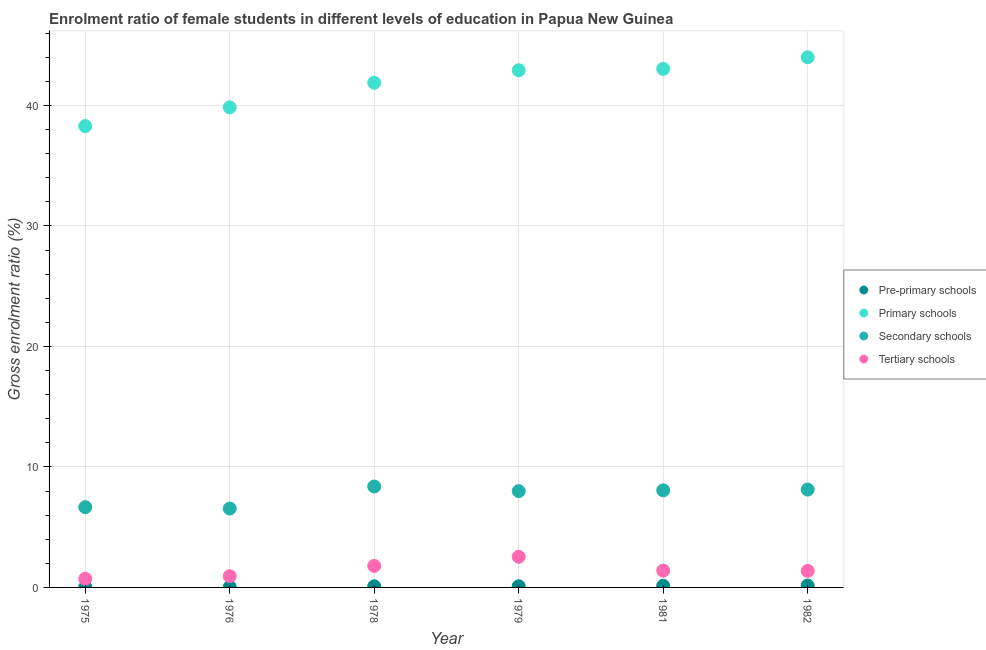How many different coloured dotlines are there?
Offer a terse response. 4. What is the gross enrolment ratio(male) in secondary schools in 1975?
Provide a succinct answer. 6.66. Across all years, what is the maximum gross enrolment ratio(male) in tertiary schools?
Your response must be concise. 2.54. Across all years, what is the minimum gross enrolment ratio(male) in secondary schools?
Your answer should be very brief. 6.55. In which year was the gross enrolment ratio(male) in tertiary schools maximum?
Your answer should be compact. 1979. In which year was the gross enrolment ratio(male) in tertiary schools minimum?
Offer a terse response. 1975. What is the total gross enrolment ratio(male) in primary schools in the graph?
Give a very brief answer. 249.93. What is the difference between the gross enrolment ratio(male) in tertiary schools in 1981 and that in 1982?
Keep it short and to the point. 0.02. What is the difference between the gross enrolment ratio(male) in pre-primary schools in 1981 and the gross enrolment ratio(male) in primary schools in 1979?
Your response must be concise. -42.78. What is the average gross enrolment ratio(male) in primary schools per year?
Offer a very short reply. 41.66. In the year 1978, what is the difference between the gross enrolment ratio(male) in tertiary schools and gross enrolment ratio(male) in pre-primary schools?
Provide a succinct answer. 1.69. What is the ratio of the gross enrolment ratio(male) in pre-primary schools in 1976 to that in 1979?
Offer a very short reply. 0.39. Is the gross enrolment ratio(male) in primary schools in 1979 less than that in 1982?
Offer a very short reply. Yes. What is the difference between the highest and the second highest gross enrolment ratio(male) in primary schools?
Offer a very short reply. 0.96. What is the difference between the highest and the lowest gross enrolment ratio(male) in secondary schools?
Give a very brief answer. 1.83. In how many years, is the gross enrolment ratio(male) in tertiary schools greater than the average gross enrolment ratio(male) in tertiary schools taken over all years?
Give a very brief answer. 2. Is it the case that in every year, the sum of the gross enrolment ratio(male) in tertiary schools and gross enrolment ratio(male) in primary schools is greater than the sum of gross enrolment ratio(male) in pre-primary schools and gross enrolment ratio(male) in secondary schools?
Offer a terse response. No. Is it the case that in every year, the sum of the gross enrolment ratio(male) in pre-primary schools and gross enrolment ratio(male) in primary schools is greater than the gross enrolment ratio(male) in secondary schools?
Your answer should be very brief. Yes. Is the gross enrolment ratio(male) in pre-primary schools strictly less than the gross enrolment ratio(male) in secondary schools over the years?
Your answer should be compact. Yes. How many years are there in the graph?
Your response must be concise. 6. Does the graph contain any zero values?
Your response must be concise. No. Does the graph contain grids?
Your answer should be compact. Yes. How many legend labels are there?
Give a very brief answer. 4. What is the title of the graph?
Keep it short and to the point. Enrolment ratio of female students in different levels of education in Papua New Guinea. Does "UNPBF" appear as one of the legend labels in the graph?
Offer a terse response. No. What is the label or title of the X-axis?
Offer a terse response. Year. What is the label or title of the Y-axis?
Ensure brevity in your answer.  Gross enrolment ratio (%). What is the Gross enrolment ratio (%) in Pre-primary schools in 1975?
Provide a short and direct response. 0.03. What is the Gross enrolment ratio (%) of Primary schools in 1975?
Provide a succinct answer. 38.28. What is the Gross enrolment ratio (%) in Secondary schools in 1975?
Make the answer very short. 6.66. What is the Gross enrolment ratio (%) of Tertiary schools in 1975?
Keep it short and to the point. 0.72. What is the Gross enrolment ratio (%) in Pre-primary schools in 1976?
Provide a succinct answer. 0.04. What is the Gross enrolment ratio (%) in Primary schools in 1976?
Offer a very short reply. 39.84. What is the Gross enrolment ratio (%) of Secondary schools in 1976?
Offer a terse response. 6.55. What is the Gross enrolment ratio (%) of Tertiary schools in 1976?
Offer a terse response. 0.93. What is the Gross enrolment ratio (%) in Pre-primary schools in 1978?
Your response must be concise. 0.09. What is the Gross enrolment ratio (%) of Primary schools in 1978?
Your response must be concise. 41.88. What is the Gross enrolment ratio (%) in Secondary schools in 1978?
Your answer should be very brief. 8.37. What is the Gross enrolment ratio (%) of Tertiary schools in 1978?
Your response must be concise. 1.79. What is the Gross enrolment ratio (%) of Pre-primary schools in 1979?
Make the answer very short. 0.1. What is the Gross enrolment ratio (%) of Primary schools in 1979?
Your answer should be very brief. 42.92. What is the Gross enrolment ratio (%) of Secondary schools in 1979?
Provide a succinct answer. 7.99. What is the Gross enrolment ratio (%) of Tertiary schools in 1979?
Provide a short and direct response. 2.54. What is the Gross enrolment ratio (%) of Pre-primary schools in 1981?
Your response must be concise. 0.14. What is the Gross enrolment ratio (%) of Primary schools in 1981?
Your answer should be compact. 43.03. What is the Gross enrolment ratio (%) in Secondary schools in 1981?
Your answer should be compact. 8.06. What is the Gross enrolment ratio (%) of Tertiary schools in 1981?
Offer a very short reply. 1.39. What is the Gross enrolment ratio (%) in Pre-primary schools in 1982?
Offer a very short reply. 0.15. What is the Gross enrolment ratio (%) of Primary schools in 1982?
Provide a succinct answer. 43.99. What is the Gross enrolment ratio (%) of Secondary schools in 1982?
Your answer should be very brief. 8.12. What is the Gross enrolment ratio (%) in Tertiary schools in 1982?
Provide a succinct answer. 1.37. Across all years, what is the maximum Gross enrolment ratio (%) of Pre-primary schools?
Offer a very short reply. 0.15. Across all years, what is the maximum Gross enrolment ratio (%) of Primary schools?
Your answer should be very brief. 43.99. Across all years, what is the maximum Gross enrolment ratio (%) of Secondary schools?
Offer a very short reply. 8.37. Across all years, what is the maximum Gross enrolment ratio (%) in Tertiary schools?
Keep it short and to the point. 2.54. Across all years, what is the minimum Gross enrolment ratio (%) in Pre-primary schools?
Keep it short and to the point. 0.03. Across all years, what is the minimum Gross enrolment ratio (%) of Primary schools?
Offer a very short reply. 38.28. Across all years, what is the minimum Gross enrolment ratio (%) in Secondary schools?
Make the answer very short. 6.55. Across all years, what is the minimum Gross enrolment ratio (%) in Tertiary schools?
Give a very brief answer. 0.72. What is the total Gross enrolment ratio (%) in Pre-primary schools in the graph?
Keep it short and to the point. 0.54. What is the total Gross enrolment ratio (%) of Primary schools in the graph?
Provide a short and direct response. 249.93. What is the total Gross enrolment ratio (%) of Secondary schools in the graph?
Your answer should be very brief. 45.75. What is the total Gross enrolment ratio (%) in Tertiary schools in the graph?
Provide a succinct answer. 8.74. What is the difference between the Gross enrolment ratio (%) of Pre-primary schools in 1975 and that in 1976?
Provide a succinct answer. -0.01. What is the difference between the Gross enrolment ratio (%) of Primary schools in 1975 and that in 1976?
Provide a succinct answer. -1.55. What is the difference between the Gross enrolment ratio (%) of Secondary schools in 1975 and that in 1976?
Your response must be concise. 0.11. What is the difference between the Gross enrolment ratio (%) of Tertiary schools in 1975 and that in 1976?
Give a very brief answer. -0.21. What is the difference between the Gross enrolment ratio (%) of Pre-primary schools in 1975 and that in 1978?
Provide a short and direct response. -0.07. What is the difference between the Gross enrolment ratio (%) in Primary schools in 1975 and that in 1978?
Your response must be concise. -3.6. What is the difference between the Gross enrolment ratio (%) in Secondary schools in 1975 and that in 1978?
Keep it short and to the point. -1.72. What is the difference between the Gross enrolment ratio (%) in Tertiary schools in 1975 and that in 1978?
Your answer should be compact. -1.07. What is the difference between the Gross enrolment ratio (%) in Pre-primary schools in 1975 and that in 1979?
Your answer should be compact. -0.07. What is the difference between the Gross enrolment ratio (%) in Primary schools in 1975 and that in 1979?
Give a very brief answer. -4.63. What is the difference between the Gross enrolment ratio (%) in Secondary schools in 1975 and that in 1979?
Your answer should be compact. -1.33. What is the difference between the Gross enrolment ratio (%) in Tertiary schools in 1975 and that in 1979?
Offer a terse response. -1.82. What is the difference between the Gross enrolment ratio (%) of Pre-primary schools in 1975 and that in 1981?
Offer a very short reply. -0.11. What is the difference between the Gross enrolment ratio (%) in Primary schools in 1975 and that in 1981?
Offer a very short reply. -4.75. What is the difference between the Gross enrolment ratio (%) of Secondary schools in 1975 and that in 1981?
Keep it short and to the point. -1.4. What is the difference between the Gross enrolment ratio (%) in Tertiary schools in 1975 and that in 1981?
Give a very brief answer. -0.67. What is the difference between the Gross enrolment ratio (%) in Pre-primary schools in 1975 and that in 1982?
Your response must be concise. -0.13. What is the difference between the Gross enrolment ratio (%) in Primary schools in 1975 and that in 1982?
Provide a succinct answer. -5.71. What is the difference between the Gross enrolment ratio (%) in Secondary schools in 1975 and that in 1982?
Offer a very short reply. -1.46. What is the difference between the Gross enrolment ratio (%) of Tertiary schools in 1975 and that in 1982?
Ensure brevity in your answer.  -0.65. What is the difference between the Gross enrolment ratio (%) of Pre-primary schools in 1976 and that in 1978?
Keep it short and to the point. -0.06. What is the difference between the Gross enrolment ratio (%) of Primary schools in 1976 and that in 1978?
Provide a succinct answer. -2.04. What is the difference between the Gross enrolment ratio (%) in Secondary schools in 1976 and that in 1978?
Make the answer very short. -1.83. What is the difference between the Gross enrolment ratio (%) of Tertiary schools in 1976 and that in 1978?
Provide a succinct answer. -0.85. What is the difference between the Gross enrolment ratio (%) in Pre-primary schools in 1976 and that in 1979?
Your answer should be compact. -0.06. What is the difference between the Gross enrolment ratio (%) in Primary schools in 1976 and that in 1979?
Provide a short and direct response. -3.08. What is the difference between the Gross enrolment ratio (%) in Secondary schools in 1976 and that in 1979?
Your answer should be very brief. -1.45. What is the difference between the Gross enrolment ratio (%) in Tertiary schools in 1976 and that in 1979?
Your answer should be very brief. -1.61. What is the difference between the Gross enrolment ratio (%) in Pre-primary schools in 1976 and that in 1981?
Keep it short and to the point. -0.1. What is the difference between the Gross enrolment ratio (%) of Primary schools in 1976 and that in 1981?
Ensure brevity in your answer.  -3.19. What is the difference between the Gross enrolment ratio (%) of Secondary schools in 1976 and that in 1981?
Provide a short and direct response. -1.51. What is the difference between the Gross enrolment ratio (%) in Tertiary schools in 1976 and that in 1981?
Offer a terse response. -0.46. What is the difference between the Gross enrolment ratio (%) in Pre-primary schools in 1976 and that in 1982?
Provide a short and direct response. -0.12. What is the difference between the Gross enrolment ratio (%) in Primary schools in 1976 and that in 1982?
Your answer should be very brief. -4.15. What is the difference between the Gross enrolment ratio (%) in Secondary schools in 1976 and that in 1982?
Your response must be concise. -1.57. What is the difference between the Gross enrolment ratio (%) of Tertiary schools in 1976 and that in 1982?
Offer a terse response. -0.44. What is the difference between the Gross enrolment ratio (%) of Pre-primary schools in 1978 and that in 1979?
Offer a terse response. -0. What is the difference between the Gross enrolment ratio (%) of Primary schools in 1978 and that in 1979?
Your answer should be very brief. -1.04. What is the difference between the Gross enrolment ratio (%) in Secondary schools in 1978 and that in 1979?
Your answer should be very brief. 0.38. What is the difference between the Gross enrolment ratio (%) in Tertiary schools in 1978 and that in 1979?
Keep it short and to the point. -0.75. What is the difference between the Gross enrolment ratio (%) of Pre-primary schools in 1978 and that in 1981?
Your response must be concise. -0.04. What is the difference between the Gross enrolment ratio (%) in Primary schools in 1978 and that in 1981?
Provide a succinct answer. -1.15. What is the difference between the Gross enrolment ratio (%) of Secondary schools in 1978 and that in 1981?
Give a very brief answer. 0.32. What is the difference between the Gross enrolment ratio (%) in Tertiary schools in 1978 and that in 1981?
Keep it short and to the point. 0.4. What is the difference between the Gross enrolment ratio (%) in Pre-primary schools in 1978 and that in 1982?
Keep it short and to the point. -0.06. What is the difference between the Gross enrolment ratio (%) in Primary schools in 1978 and that in 1982?
Offer a very short reply. -2.11. What is the difference between the Gross enrolment ratio (%) of Secondary schools in 1978 and that in 1982?
Make the answer very short. 0.25. What is the difference between the Gross enrolment ratio (%) in Tertiary schools in 1978 and that in 1982?
Ensure brevity in your answer.  0.42. What is the difference between the Gross enrolment ratio (%) in Pre-primary schools in 1979 and that in 1981?
Keep it short and to the point. -0.04. What is the difference between the Gross enrolment ratio (%) in Primary schools in 1979 and that in 1981?
Offer a very short reply. -0.11. What is the difference between the Gross enrolment ratio (%) of Secondary schools in 1979 and that in 1981?
Keep it short and to the point. -0.06. What is the difference between the Gross enrolment ratio (%) of Tertiary schools in 1979 and that in 1981?
Keep it short and to the point. 1.15. What is the difference between the Gross enrolment ratio (%) in Pre-primary schools in 1979 and that in 1982?
Offer a very short reply. -0.06. What is the difference between the Gross enrolment ratio (%) in Primary schools in 1979 and that in 1982?
Your answer should be very brief. -1.07. What is the difference between the Gross enrolment ratio (%) in Secondary schools in 1979 and that in 1982?
Offer a very short reply. -0.13. What is the difference between the Gross enrolment ratio (%) of Tertiary schools in 1979 and that in 1982?
Ensure brevity in your answer.  1.17. What is the difference between the Gross enrolment ratio (%) of Pre-primary schools in 1981 and that in 1982?
Keep it short and to the point. -0.02. What is the difference between the Gross enrolment ratio (%) of Primary schools in 1981 and that in 1982?
Provide a short and direct response. -0.96. What is the difference between the Gross enrolment ratio (%) of Secondary schools in 1981 and that in 1982?
Provide a short and direct response. -0.06. What is the difference between the Gross enrolment ratio (%) of Tertiary schools in 1981 and that in 1982?
Provide a succinct answer. 0.02. What is the difference between the Gross enrolment ratio (%) in Pre-primary schools in 1975 and the Gross enrolment ratio (%) in Primary schools in 1976?
Your response must be concise. -39.81. What is the difference between the Gross enrolment ratio (%) of Pre-primary schools in 1975 and the Gross enrolment ratio (%) of Secondary schools in 1976?
Your response must be concise. -6.52. What is the difference between the Gross enrolment ratio (%) in Pre-primary schools in 1975 and the Gross enrolment ratio (%) in Tertiary schools in 1976?
Ensure brevity in your answer.  -0.91. What is the difference between the Gross enrolment ratio (%) in Primary schools in 1975 and the Gross enrolment ratio (%) in Secondary schools in 1976?
Ensure brevity in your answer.  31.73. What is the difference between the Gross enrolment ratio (%) in Primary schools in 1975 and the Gross enrolment ratio (%) in Tertiary schools in 1976?
Give a very brief answer. 37.35. What is the difference between the Gross enrolment ratio (%) of Secondary schools in 1975 and the Gross enrolment ratio (%) of Tertiary schools in 1976?
Provide a short and direct response. 5.73. What is the difference between the Gross enrolment ratio (%) in Pre-primary schools in 1975 and the Gross enrolment ratio (%) in Primary schools in 1978?
Make the answer very short. -41.85. What is the difference between the Gross enrolment ratio (%) of Pre-primary schools in 1975 and the Gross enrolment ratio (%) of Secondary schools in 1978?
Provide a short and direct response. -8.35. What is the difference between the Gross enrolment ratio (%) in Pre-primary schools in 1975 and the Gross enrolment ratio (%) in Tertiary schools in 1978?
Make the answer very short. -1.76. What is the difference between the Gross enrolment ratio (%) of Primary schools in 1975 and the Gross enrolment ratio (%) of Secondary schools in 1978?
Your response must be concise. 29.91. What is the difference between the Gross enrolment ratio (%) in Primary schools in 1975 and the Gross enrolment ratio (%) in Tertiary schools in 1978?
Ensure brevity in your answer.  36.49. What is the difference between the Gross enrolment ratio (%) in Secondary schools in 1975 and the Gross enrolment ratio (%) in Tertiary schools in 1978?
Your response must be concise. 4.87. What is the difference between the Gross enrolment ratio (%) in Pre-primary schools in 1975 and the Gross enrolment ratio (%) in Primary schools in 1979?
Keep it short and to the point. -42.89. What is the difference between the Gross enrolment ratio (%) of Pre-primary schools in 1975 and the Gross enrolment ratio (%) of Secondary schools in 1979?
Your response must be concise. -7.97. What is the difference between the Gross enrolment ratio (%) of Pre-primary schools in 1975 and the Gross enrolment ratio (%) of Tertiary schools in 1979?
Offer a terse response. -2.51. What is the difference between the Gross enrolment ratio (%) in Primary schools in 1975 and the Gross enrolment ratio (%) in Secondary schools in 1979?
Your answer should be compact. 30.29. What is the difference between the Gross enrolment ratio (%) of Primary schools in 1975 and the Gross enrolment ratio (%) of Tertiary schools in 1979?
Offer a terse response. 35.74. What is the difference between the Gross enrolment ratio (%) in Secondary schools in 1975 and the Gross enrolment ratio (%) in Tertiary schools in 1979?
Offer a very short reply. 4.12. What is the difference between the Gross enrolment ratio (%) of Pre-primary schools in 1975 and the Gross enrolment ratio (%) of Primary schools in 1981?
Ensure brevity in your answer.  -43.01. What is the difference between the Gross enrolment ratio (%) of Pre-primary schools in 1975 and the Gross enrolment ratio (%) of Secondary schools in 1981?
Your answer should be compact. -8.03. What is the difference between the Gross enrolment ratio (%) in Pre-primary schools in 1975 and the Gross enrolment ratio (%) in Tertiary schools in 1981?
Your answer should be compact. -1.37. What is the difference between the Gross enrolment ratio (%) in Primary schools in 1975 and the Gross enrolment ratio (%) in Secondary schools in 1981?
Give a very brief answer. 30.22. What is the difference between the Gross enrolment ratio (%) of Primary schools in 1975 and the Gross enrolment ratio (%) of Tertiary schools in 1981?
Offer a terse response. 36.89. What is the difference between the Gross enrolment ratio (%) in Secondary schools in 1975 and the Gross enrolment ratio (%) in Tertiary schools in 1981?
Ensure brevity in your answer.  5.27. What is the difference between the Gross enrolment ratio (%) of Pre-primary schools in 1975 and the Gross enrolment ratio (%) of Primary schools in 1982?
Your answer should be compact. -43.96. What is the difference between the Gross enrolment ratio (%) of Pre-primary schools in 1975 and the Gross enrolment ratio (%) of Secondary schools in 1982?
Your response must be concise. -8.1. What is the difference between the Gross enrolment ratio (%) of Pre-primary schools in 1975 and the Gross enrolment ratio (%) of Tertiary schools in 1982?
Offer a terse response. -1.34. What is the difference between the Gross enrolment ratio (%) in Primary schools in 1975 and the Gross enrolment ratio (%) in Secondary schools in 1982?
Your answer should be compact. 30.16. What is the difference between the Gross enrolment ratio (%) of Primary schools in 1975 and the Gross enrolment ratio (%) of Tertiary schools in 1982?
Give a very brief answer. 36.91. What is the difference between the Gross enrolment ratio (%) of Secondary schools in 1975 and the Gross enrolment ratio (%) of Tertiary schools in 1982?
Keep it short and to the point. 5.29. What is the difference between the Gross enrolment ratio (%) in Pre-primary schools in 1976 and the Gross enrolment ratio (%) in Primary schools in 1978?
Offer a terse response. -41.84. What is the difference between the Gross enrolment ratio (%) in Pre-primary schools in 1976 and the Gross enrolment ratio (%) in Secondary schools in 1978?
Provide a succinct answer. -8.34. What is the difference between the Gross enrolment ratio (%) in Pre-primary schools in 1976 and the Gross enrolment ratio (%) in Tertiary schools in 1978?
Offer a very short reply. -1.75. What is the difference between the Gross enrolment ratio (%) in Primary schools in 1976 and the Gross enrolment ratio (%) in Secondary schools in 1978?
Offer a very short reply. 31.46. What is the difference between the Gross enrolment ratio (%) of Primary schools in 1976 and the Gross enrolment ratio (%) of Tertiary schools in 1978?
Make the answer very short. 38.05. What is the difference between the Gross enrolment ratio (%) of Secondary schools in 1976 and the Gross enrolment ratio (%) of Tertiary schools in 1978?
Offer a very short reply. 4.76. What is the difference between the Gross enrolment ratio (%) of Pre-primary schools in 1976 and the Gross enrolment ratio (%) of Primary schools in 1979?
Your response must be concise. -42.88. What is the difference between the Gross enrolment ratio (%) of Pre-primary schools in 1976 and the Gross enrolment ratio (%) of Secondary schools in 1979?
Keep it short and to the point. -7.96. What is the difference between the Gross enrolment ratio (%) in Pre-primary schools in 1976 and the Gross enrolment ratio (%) in Tertiary schools in 1979?
Ensure brevity in your answer.  -2.5. What is the difference between the Gross enrolment ratio (%) of Primary schools in 1976 and the Gross enrolment ratio (%) of Secondary schools in 1979?
Your response must be concise. 31.84. What is the difference between the Gross enrolment ratio (%) in Primary schools in 1976 and the Gross enrolment ratio (%) in Tertiary schools in 1979?
Your answer should be compact. 37.3. What is the difference between the Gross enrolment ratio (%) of Secondary schools in 1976 and the Gross enrolment ratio (%) of Tertiary schools in 1979?
Provide a succinct answer. 4.01. What is the difference between the Gross enrolment ratio (%) of Pre-primary schools in 1976 and the Gross enrolment ratio (%) of Primary schools in 1981?
Your answer should be compact. -42.99. What is the difference between the Gross enrolment ratio (%) in Pre-primary schools in 1976 and the Gross enrolment ratio (%) in Secondary schools in 1981?
Give a very brief answer. -8.02. What is the difference between the Gross enrolment ratio (%) of Pre-primary schools in 1976 and the Gross enrolment ratio (%) of Tertiary schools in 1981?
Ensure brevity in your answer.  -1.35. What is the difference between the Gross enrolment ratio (%) of Primary schools in 1976 and the Gross enrolment ratio (%) of Secondary schools in 1981?
Offer a terse response. 31.78. What is the difference between the Gross enrolment ratio (%) in Primary schools in 1976 and the Gross enrolment ratio (%) in Tertiary schools in 1981?
Your response must be concise. 38.45. What is the difference between the Gross enrolment ratio (%) of Secondary schools in 1976 and the Gross enrolment ratio (%) of Tertiary schools in 1981?
Your answer should be compact. 5.16. What is the difference between the Gross enrolment ratio (%) of Pre-primary schools in 1976 and the Gross enrolment ratio (%) of Primary schools in 1982?
Your answer should be compact. -43.95. What is the difference between the Gross enrolment ratio (%) in Pre-primary schools in 1976 and the Gross enrolment ratio (%) in Secondary schools in 1982?
Your answer should be compact. -8.08. What is the difference between the Gross enrolment ratio (%) of Pre-primary schools in 1976 and the Gross enrolment ratio (%) of Tertiary schools in 1982?
Offer a terse response. -1.33. What is the difference between the Gross enrolment ratio (%) of Primary schools in 1976 and the Gross enrolment ratio (%) of Secondary schools in 1982?
Provide a succinct answer. 31.71. What is the difference between the Gross enrolment ratio (%) of Primary schools in 1976 and the Gross enrolment ratio (%) of Tertiary schools in 1982?
Give a very brief answer. 38.47. What is the difference between the Gross enrolment ratio (%) in Secondary schools in 1976 and the Gross enrolment ratio (%) in Tertiary schools in 1982?
Your response must be concise. 5.18. What is the difference between the Gross enrolment ratio (%) of Pre-primary schools in 1978 and the Gross enrolment ratio (%) of Primary schools in 1979?
Keep it short and to the point. -42.82. What is the difference between the Gross enrolment ratio (%) of Pre-primary schools in 1978 and the Gross enrolment ratio (%) of Secondary schools in 1979?
Provide a short and direct response. -7.9. What is the difference between the Gross enrolment ratio (%) in Pre-primary schools in 1978 and the Gross enrolment ratio (%) in Tertiary schools in 1979?
Provide a succinct answer. -2.45. What is the difference between the Gross enrolment ratio (%) of Primary schools in 1978 and the Gross enrolment ratio (%) of Secondary schools in 1979?
Offer a terse response. 33.89. What is the difference between the Gross enrolment ratio (%) in Primary schools in 1978 and the Gross enrolment ratio (%) in Tertiary schools in 1979?
Your response must be concise. 39.34. What is the difference between the Gross enrolment ratio (%) of Secondary schools in 1978 and the Gross enrolment ratio (%) of Tertiary schools in 1979?
Offer a terse response. 5.84. What is the difference between the Gross enrolment ratio (%) of Pre-primary schools in 1978 and the Gross enrolment ratio (%) of Primary schools in 1981?
Your answer should be compact. -42.94. What is the difference between the Gross enrolment ratio (%) of Pre-primary schools in 1978 and the Gross enrolment ratio (%) of Secondary schools in 1981?
Provide a succinct answer. -7.96. What is the difference between the Gross enrolment ratio (%) in Pre-primary schools in 1978 and the Gross enrolment ratio (%) in Tertiary schools in 1981?
Offer a terse response. -1.3. What is the difference between the Gross enrolment ratio (%) in Primary schools in 1978 and the Gross enrolment ratio (%) in Secondary schools in 1981?
Offer a very short reply. 33.82. What is the difference between the Gross enrolment ratio (%) of Primary schools in 1978 and the Gross enrolment ratio (%) of Tertiary schools in 1981?
Offer a very short reply. 40.49. What is the difference between the Gross enrolment ratio (%) in Secondary schools in 1978 and the Gross enrolment ratio (%) in Tertiary schools in 1981?
Offer a very short reply. 6.98. What is the difference between the Gross enrolment ratio (%) in Pre-primary schools in 1978 and the Gross enrolment ratio (%) in Primary schools in 1982?
Offer a terse response. -43.9. What is the difference between the Gross enrolment ratio (%) in Pre-primary schools in 1978 and the Gross enrolment ratio (%) in Secondary schools in 1982?
Make the answer very short. -8.03. What is the difference between the Gross enrolment ratio (%) of Pre-primary schools in 1978 and the Gross enrolment ratio (%) of Tertiary schools in 1982?
Offer a very short reply. -1.28. What is the difference between the Gross enrolment ratio (%) in Primary schools in 1978 and the Gross enrolment ratio (%) in Secondary schools in 1982?
Keep it short and to the point. 33.76. What is the difference between the Gross enrolment ratio (%) of Primary schools in 1978 and the Gross enrolment ratio (%) of Tertiary schools in 1982?
Your response must be concise. 40.51. What is the difference between the Gross enrolment ratio (%) of Secondary schools in 1978 and the Gross enrolment ratio (%) of Tertiary schools in 1982?
Your answer should be compact. 7. What is the difference between the Gross enrolment ratio (%) in Pre-primary schools in 1979 and the Gross enrolment ratio (%) in Primary schools in 1981?
Keep it short and to the point. -42.94. What is the difference between the Gross enrolment ratio (%) of Pre-primary schools in 1979 and the Gross enrolment ratio (%) of Secondary schools in 1981?
Offer a terse response. -7.96. What is the difference between the Gross enrolment ratio (%) in Pre-primary schools in 1979 and the Gross enrolment ratio (%) in Tertiary schools in 1981?
Provide a succinct answer. -1.3. What is the difference between the Gross enrolment ratio (%) in Primary schools in 1979 and the Gross enrolment ratio (%) in Secondary schools in 1981?
Make the answer very short. 34.86. What is the difference between the Gross enrolment ratio (%) of Primary schools in 1979 and the Gross enrolment ratio (%) of Tertiary schools in 1981?
Your answer should be very brief. 41.53. What is the difference between the Gross enrolment ratio (%) in Secondary schools in 1979 and the Gross enrolment ratio (%) in Tertiary schools in 1981?
Offer a terse response. 6.6. What is the difference between the Gross enrolment ratio (%) in Pre-primary schools in 1979 and the Gross enrolment ratio (%) in Primary schools in 1982?
Provide a succinct answer. -43.89. What is the difference between the Gross enrolment ratio (%) in Pre-primary schools in 1979 and the Gross enrolment ratio (%) in Secondary schools in 1982?
Provide a succinct answer. -8.03. What is the difference between the Gross enrolment ratio (%) of Pre-primary schools in 1979 and the Gross enrolment ratio (%) of Tertiary schools in 1982?
Keep it short and to the point. -1.27. What is the difference between the Gross enrolment ratio (%) of Primary schools in 1979 and the Gross enrolment ratio (%) of Secondary schools in 1982?
Ensure brevity in your answer.  34.79. What is the difference between the Gross enrolment ratio (%) in Primary schools in 1979 and the Gross enrolment ratio (%) in Tertiary schools in 1982?
Give a very brief answer. 41.55. What is the difference between the Gross enrolment ratio (%) in Secondary schools in 1979 and the Gross enrolment ratio (%) in Tertiary schools in 1982?
Keep it short and to the point. 6.62. What is the difference between the Gross enrolment ratio (%) of Pre-primary schools in 1981 and the Gross enrolment ratio (%) of Primary schools in 1982?
Your answer should be very brief. -43.85. What is the difference between the Gross enrolment ratio (%) in Pre-primary schools in 1981 and the Gross enrolment ratio (%) in Secondary schools in 1982?
Provide a short and direct response. -7.99. What is the difference between the Gross enrolment ratio (%) in Pre-primary schools in 1981 and the Gross enrolment ratio (%) in Tertiary schools in 1982?
Ensure brevity in your answer.  -1.24. What is the difference between the Gross enrolment ratio (%) of Primary schools in 1981 and the Gross enrolment ratio (%) of Secondary schools in 1982?
Offer a very short reply. 34.91. What is the difference between the Gross enrolment ratio (%) of Primary schools in 1981 and the Gross enrolment ratio (%) of Tertiary schools in 1982?
Your answer should be compact. 41.66. What is the difference between the Gross enrolment ratio (%) of Secondary schools in 1981 and the Gross enrolment ratio (%) of Tertiary schools in 1982?
Provide a short and direct response. 6.69. What is the average Gross enrolment ratio (%) of Pre-primary schools per year?
Your answer should be very brief. 0.09. What is the average Gross enrolment ratio (%) of Primary schools per year?
Offer a very short reply. 41.66. What is the average Gross enrolment ratio (%) of Secondary schools per year?
Keep it short and to the point. 7.63. What is the average Gross enrolment ratio (%) in Tertiary schools per year?
Keep it short and to the point. 1.46. In the year 1975, what is the difference between the Gross enrolment ratio (%) of Pre-primary schools and Gross enrolment ratio (%) of Primary schools?
Make the answer very short. -38.26. In the year 1975, what is the difference between the Gross enrolment ratio (%) of Pre-primary schools and Gross enrolment ratio (%) of Secondary schools?
Your answer should be very brief. -6.63. In the year 1975, what is the difference between the Gross enrolment ratio (%) of Pre-primary schools and Gross enrolment ratio (%) of Tertiary schools?
Provide a short and direct response. -0.69. In the year 1975, what is the difference between the Gross enrolment ratio (%) in Primary schools and Gross enrolment ratio (%) in Secondary schools?
Provide a short and direct response. 31.62. In the year 1975, what is the difference between the Gross enrolment ratio (%) in Primary schools and Gross enrolment ratio (%) in Tertiary schools?
Keep it short and to the point. 37.56. In the year 1975, what is the difference between the Gross enrolment ratio (%) of Secondary schools and Gross enrolment ratio (%) of Tertiary schools?
Offer a very short reply. 5.94. In the year 1976, what is the difference between the Gross enrolment ratio (%) of Pre-primary schools and Gross enrolment ratio (%) of Primary schools?
Your answer should be very brief. -39.8. In the year 1976, what is the difference between the Gross enrolment ratio (%) in Pre-primary schools and Gross enrolment ratio (%) in Secondary schools?
Make the answer very short. -6.51. In the year 1976, what is the difference between the Gross enrolment ratio (%) of Pre-primary schools and Gross enrolment ratio (%) of Tertiary schools?
Make the answer very short. -0.9. In the year 1976, what is the difference between the Gross enrolment ratio (%) of Primary schools and Gross enrolment ratio (%) of Secondary schools?
Your response must be concise. 33.29. In the year 1976, what is the difference between the Gross enrolment ratio (%) of Primary schools and Gross enrolment ratio (%) of Tertiary schools?
Your response must be concise. 38.9. In the year 1976, what is the difference between the Gross enrolment ratio (%) of Secondary schools and Gross enrolment ratio (%) of Tertiary schools?
Give a very brief answer. 5.61. In the year 1978, what is the difference between the Gross enrolment ratio (%) in Pre-primary schools and Gross enrolment ratio (%) in Primary schools?
Your response must be concise. -41.78. In the year 1978, what is the difference between the Gross enrolment ratio (%) of Pre-primary schools and Gross enrolment ratio (%) of Secondary schools?
Provide a short and direct response. -8.28. In the year 1978, what is the difference between the Gross enrolment ratio (%) in Pre-primary schools and Gross enrolment ratio (%) in Tertiary schools?
Offer a terse response. -1.69. In the year 1978, what is the difference between the Gross enrolment ratio (%) of Primary schools and Gross enrolment ratio (%) of Secondary schools?
Keep it short and to the point. 33.5. In the year 1978, what is the difference between the Gross enrolment ratio (%) of Primary schools and Gross enrolment ratio (%) of Tertiary schools?
Provide a short and direct response. 40.09. In the year 1978, what is the difference between the Gross enrolment ratio (%) of Secondary schools and Gross enrolment ratio (%) of Tertiary schools?
Ensure brevity in your answer.  6.59. In the year 1979, what is the difference between the Gross enrolment ratio (%) of Pre-primary schools and Gross enrolment ratio (%) of Primary schools?
Your answer should be very brief. -42.82. In the year 1979, what is the difference between the Gross enrolment ratio (%) in Pre-primary schools and Gross enrolment ratio (%) in Secondary schools?
Your response must be concise. -7.9. In the year 1979, what is the difference between the Gross enrolment ratio (%) in Pre-primary schools and Gross enrolment ratio (%) in Tertiary schools?
Give a very brief answer. -2.44. In the year 1979, what is the difference between the Gross enrolment ratio (%) in Primary schools and Gross enrolment ratio (%) in Secondary schools?
Your answer should be compact. 34.92. In the year 1979, what is the difference between the Gross enrolment ratio (%) of Primary schools and Gross enrolment ratio (%) of Tertiary schools?
Offer a very short reply. 40.38. In the year 1979, what is the difference between the Gross enrolment ratio (%) of Secondary schools and Gross enrolment ratio (%) of Tertiary schools?
Make the answer very short. 5.45. In the year 1981, what is the difference between the Gross enrolment ratio (%) in Pre-primary schools and Gross enrolment ratio (%) in Primary schools?
Provide a short and direct response. -42.9. In the year 1981, what is the difference between the Gross enrolment ratio (%) of Pre-primary schools and Gross enrolment ratio (%) of Secondary schools?
Your response must be concise. -7.92. In the year 1981, what is the difference between the Gross enrolment ratio (%) of Pre-primary schools and Gross enrolment ratio (%) of Tertiary schools?
Offer a terse response. -1.26. In the year 1981, what is the difference between the Gross enrolment ratio (%) in Primary schools and Gross enrolment ratio (%) in Secondary schools?
Make the answer very short. 34.97. In the year 1981, what is the difference between the Gross enrolment ratio (%) of Primary schools and Gross enrolment ratio (%) of Tertiary schools?
Make the answer very short. 41.64. In the year 1981, what is the difference between the Gross enrolment ratio (%) in Secondary schools and Gross enrolment ratio (%) in Tertiary schools?
Ensure brevity in your answer.  6.67. In the year 1982, what is the difference between the Gross enrolment ratio (%) in Pre-primary schools and Gross enrolment ratio (%) in Primary schools?
Offer a terse response. -43.84. In the year 1982, what is the difference between the Gross enrolment ratio (%) of Pre-primary schools and Gross enrolment ratio (%) of Secondary schools?
Make the answer very short. -7.97. In the year 1982, what is the difference between the Gross enrolment ratio (%) in Pre-primary schools and Gross enrolment ratio (%) in Tertiary schools?
Your response must be concise. -1.22. In the year 1982, what is the difference between the Gross enrolment ratio (%) of Primary schools and Gross enrolment ratio (%) of Secondary schools?
Offer a very short reply. 35.87. In the year 1982, what is the difference between the Gross enrolment ratio (%) in Primary schools and Gross enrolment ratio (%) in Tertiary schools?
Offer a terse response. 42.62. In the year 1982, what is the difference between the Gross enrolment ratio (%) in Secondary schools and Gross enrolment ratio (%) in Tertiary schools?
Ensure brevity in your answer.  6.75. What is the ratio of the Gross enrolment ratio (%) of Pre-primary schools in 1975 to that in 1976?
Provide a succinct answer. 0.69. What is the ratio of the Gross enrolment ratio (%) of Primary schools in 1975 to that in 1976?
Ensure brevity in your answer.  0.96. What is the ratio of the Gross enrolment ratio (%) in Secondary schools in 1975 to that in 1976?
Ensure brevity in your answer.  1.02. What is the ratio of the Gross enrolment ratio (%) in Tertiary schools in 1975 to that in 1976?
Provide a succinct answer. 0.77. What is the ratio of the Gross enrolment ratio (%) in Pre-primary schools in 1975 to that in 1978?
Give a very brief answer. 0.28. What is the ratio of the Gross enrolment ratio (%) of Primary schools in 1975 to that in 1978?
Provide a short and direct response. 0.91. What is the ratio of the Gross enrolment ratio (%) in Secondary schools in 1975 to that in 1978?
Provide a short and direct response. 0.8. What is the ratio of the Gross enrolment ratio (%) in Tertiary schools in 1975 to that in 1978?
Make the answer very short. 0.4. What is the ratio of the Gross enrolment ratio (%) of Pre-primary schools in 1975 to that in 1979?
Provide a short and direct response. 0.27. What is the ratio of the Gross enrolment ratio (%) in Primary schools in 1975 to that in 1979?
Your response must be concise. 0.89. What is the ratio of the Gross enrolment ratio (%) of Tertiary schools in 1975 to that in 1979?
Your answer should be compact. 0.28. What is the ratio of the Gross enrolment ratio (%) of Pre-primary schools in 1975 to that in 1981?
Offer a terse response. 0.19. What is the ratio of the Gross enrolment ratio (%) of Primary schools in 1975 to that in 1981?
Offer a very short reply. 0.89. What is the ratio of the Gross enrolment ratio (%) of Secondary schools in 1975 to that in 1981?
Give a very brief answer. 0.83. What is the ratio of the Gross enrolment ratio (%) in Tertiary schools in 1975 to that in 1981?
Provide a short and direct response. 0.52. What is the ratio of the Gross enrolment ratio (%) in Pre-primary schools in 1975 to that in 1982?
Your response must be concise. 0.17. What is the ratio of the Gross enrolment ratio (%) in Primary schools in 1975 to that in 1982?
Give a very brief answer. 0.87. What is the ratio of the Gross enrolment ratio (%) in Secondary schools in 1975 to that in 1982?
Provide a succinct answer. 0.82. What is the ratio of the Gross enrolment ratio (%) of Tertiary schools in 1975 to that in 1982?
Your answer should be compact. 0.52. What is the ratio of the Gross enrolment ratio (%) of Pre-primary schools in 1976 to that in 1978?
Ensure brevity in your answer.  0.4. What is the ratio of the Gross enrolment ratio (%) in Primary schools in 1976 to that in 1978?
Give a very brief answer. 0.95. What is the ratio of the Gross enrolment ratio (%) in Secondary schools in 1976 to that in 1978?
Your answer should be very brief. 0.78. What is the ratio of the Gross enrolment ratio (%) of Tertiary schools in 1976 to that in 1978?
Offer a terse response. 0.52. What is the ratio of the Gross enrolment ratio (%) in Pre-primary schools in 1976 to that in 1979?
Your response must be concise. 0.39. What is the ratio of the Gross enrolment ratio (%) in Primary schools in 1976 to that in 1979?
Offer a very short reply. 0.93. What is the ratio of the Gross enrolment ratio (%) in Secondary schools in 1976 to that in 1979?
Give a very brief answer. 0.82. What is the ratio of the Gross enrolment ratio (%) in Tertiary schools in 1976 to that in 1979?
Your response must be concise. 0.37. What is the ratio of the Gross enrolment ratio (%) of Pre-primary schools in 1976 to that in 1981?
Your answer should be very brief. 0.27. What is the ratio of the Gross enrolment ratio (%) in Primary schools in 1976 to that in 1981?
Your answer should be compact. 0.93. What is the ratio of the Gross enrolment ratio (%) in Secondary schools in 1976 to that in 1981?
Offer a very short reply. 0.81. What is the ratio of the Gross enrolment ratio (%) in Tertiary schools in 1976 to that in 1981?
Your answer should be compact. 0.67. What is the ratio of the Gross enrolment ratio (%) in Pre-primary schools in 1976 to that in 1982?
Ensure brevity in your answer.  0.24. What is the ratio of the Gross enrolment ratio (%) of Primary schools in 1976 to that in 1982?
Your answer should be very brief. 0.91. What is the ratio of the Gross enrolment ratio (%) in Secondary schools in 1976 to that in 1982?
Make the answer very short. 0.81. What is the ratio of the Gross enrolment ratio (%) in Tertiary schools in 1976 to that in 1982?
Provide a succinct answer. 0.68. What is the ratio of the Gross enrolment ratio (%) of Pre-primary schools in 1978 to that in 1979?
Keep it short and to the point. 0.97. What is the ratio of the Gross enrolment ratio (%) in Primary schools in 1978 to that in 1979?
Provide a short and direct response. 0.98. What is the ratio of the Gross enrolment ratio (%) of Secondary schools in 1978 to that in 1979?
Your response must be concise. 1.05. What is the ratio of the Gross enrolment ratio (%) in Tertiary schools in 1978 to that in 1979?
Offer a terse response. 0.7. What is the ratio of the Gross enrolment ratio (%) of Pre-primary schools in 1978 to that in 1981?
Your response must be concise. 0.68. What is the ratio of the Gross enrolment ratio (%) of Primary schools in 1978 to that in 1981?
Ensure brevity in your answer.  0.97. What is the ratio of the Gross enrolment ratio (%) of Secondary schools in 1978 to that in 1981?
Keep it short and to the point. 1.04. What is the ratio of the Gross enrolment ratio (%) in Tertiary schools in 1978 to that in 1981?
Your answer should be compact. 1.29. What is the ratio of the Gross enrolment ratio (%) of Pre-primary schools in 1978 to that in 1982?
Ensure brevity in your answer.  0.61. What is the ratio of the Gross enrolment ratio (%) in Secondary schools in 1978 to that in 1982?
Offer a terse response. 1.03. What is the ratio of the Gross enrolment ratio (%) in Tertiary schools in 1978 to that in 1982?
Provide a succinct answer. 1.3. What is the ratio of the Gross enrolment ratio (%) in Pre-primary schools in 1979 to that in 1981?
Ensure brevity in your answer.  0.71. What is the ratio of the Gross enrolment ratio (%) in Secondary schools in 1979 to that in 1981?
Your answer should be compact. 0.99. What is the ratio of the Gross enrolment ratio (%) in Tertiary schools in 1979 to that in 1981?
Give a very brief answer. 1.83. What is the ratio of the Gross enrolment ratio (%) in Pre-primary schools in 1979 to that in 1982?
Your response must be concise. 0.63. What is the ratio of the Gross enrolment ratio (%) of Primary schools in 1979 to that in 1982?
Make the answer very short. 0.98. What is the ratio of the Gross enrolment ratio (%) in Secondary schools in 1979 to that in 1982?
Make the answer very short. 0.98. What is the ratio of the Gross enrolment ratio (%) in Tertiary schools in 1979 to that in 1982?
Keep it short and to the point. 1.85. What is the ratio of the Gross enrolment ratio (%) in Pre-primary schools in 1981 to that in 1982?
Your answer should be very brief. 0.89. What is the ratio of the Gross enrolment ratio (%) in Primary schools in 1981 to that in 1982?
Offer a very short reply. 0.98. What is the ratio of the Gross enrolment ratio (%) in Tertiary schools in 1981 to that in 1982?
Make the answer very short. 1.01. What is the difference between the highest and the second highest Gross enrolment ratio (%) of Pre-primary schools?
Give a very brief answer. 0.02. What is the difference between the highest and the second highest Gross enrolment ratio (%) of Primary schools?
Offer a terse response. 0.96. What is the difference between the highest and the second highest Gross enrolment ratio (%) in Secondary schools?
Ensure brevity in your answer.  0.25. What is the difference between the highest and the second highest Gross enrolment ratio (%) in Tertiary schools?
Offer a terse response. 0.75. What is the difference between the highest and the lowest Gross enrolment ratio (%) in Pre-primary schools?
Make the answer very short. 0.13. What is the difference between the highest and the lowest Gross enrolment ratio (%) of Primary schools?
Provide a short and direct response. 5.71. What is the difference between the highest and the lowest Gross enrolment ratio (%) of Secondary schools?
Make the answer very short. 1.83. What is the difference between the highest and the lowest Gross enrolment ratio (%) of Tertiary schools?
Make the answer very short. 1.82. 